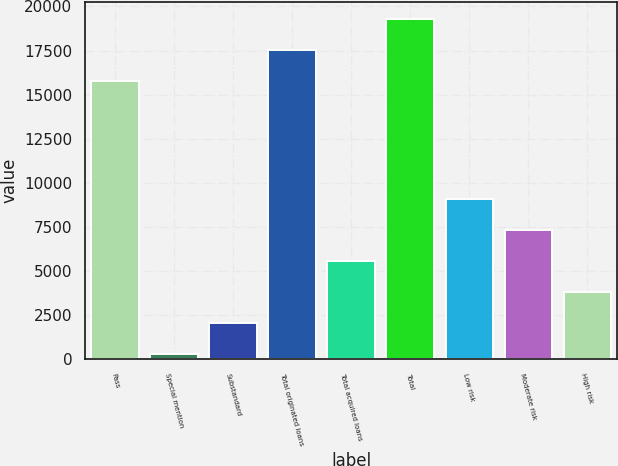<chart> <loc_0><loc_0><loc_500><loc_500><bar_chart><fcel>Pass<fcel>Special mention<fcel>Substandard<fcel>Total originated loans<fcel>Total acquired loans<fcel>Total<fcel>Low risk<fcel>Moderate risk<fcel>High risk<nl><fcel>15782.2<fcel>309<fcel>2059.78<fcel>17533<fcel>5561.34<fcel>19283.8<fcel>9062.9<fcel>7312.12<fcel>3810.56<nl></chart> 